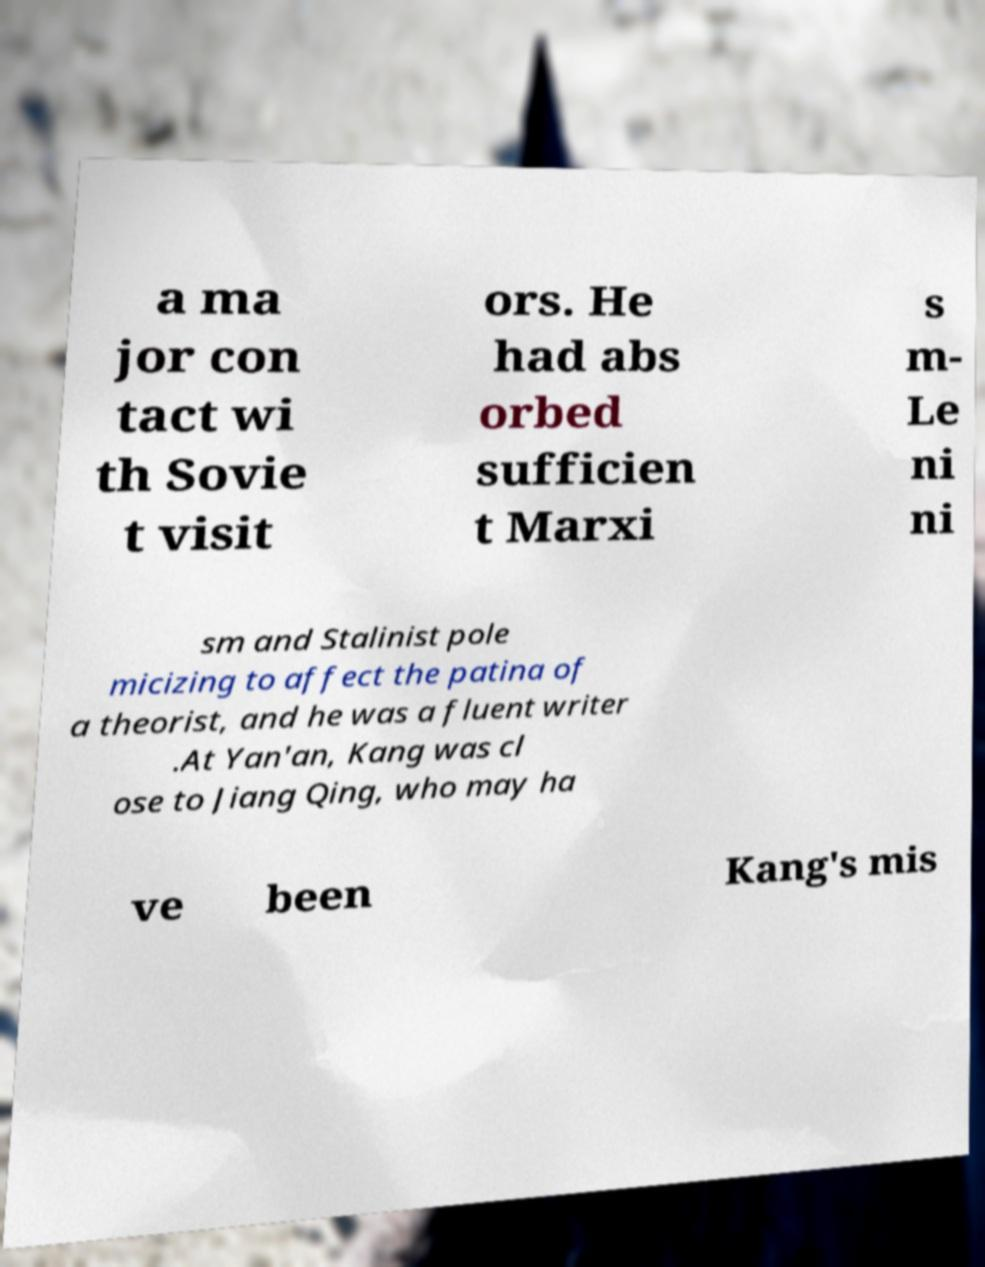Could you assist in decoding the text presented in this image and type it out clearly? a ma jor con tact wi th Sovie t visit ors. He had abs orbed sufficien t Marxi s m- Le ni ni sm and Stalinist pole micizing to affect the patina of a theorist, and he was a fluent writer .At Yan'an, Kang was cl ose to Jiang Qing, who may ha ve been Kang's mis 